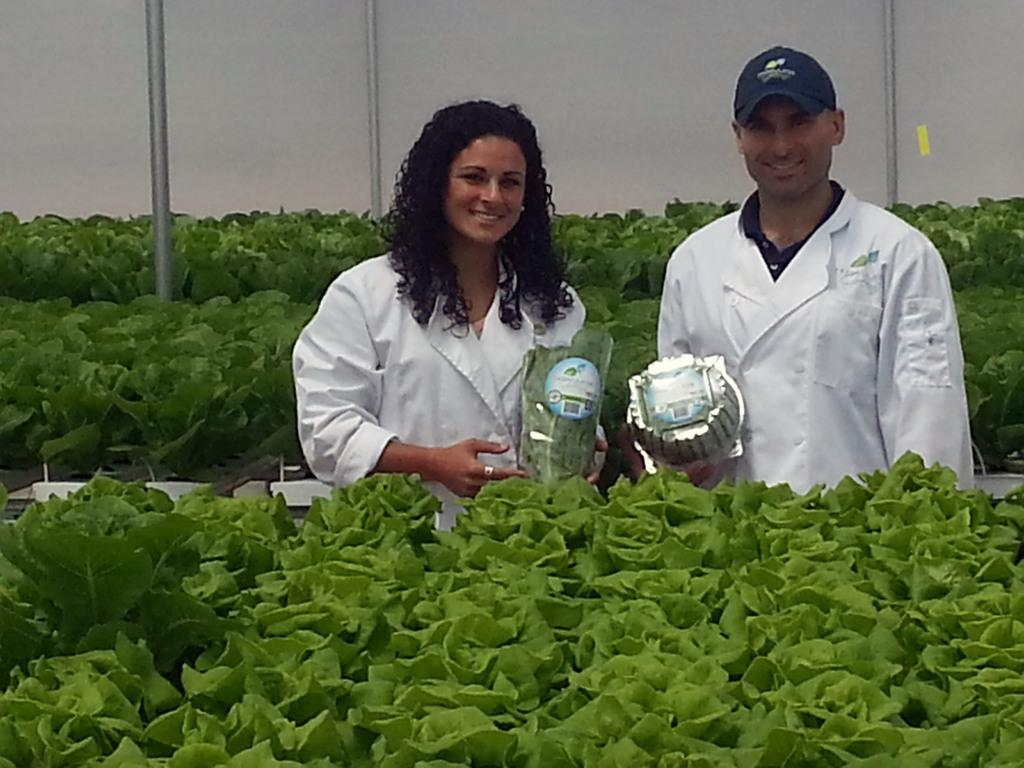How many people are in the image? There are two persons standing in the image. What are the persons holding in the image? The persons are holding objects. What type of vegetation can be seen in the image? There are plants with green color in the image. What can be seen in the background of the image? There are poles visible in the background of the image. What type of lace can be seen on the unit in the image? There is no unit or lace present in the image. How does the push of the object affect the movement of the persons in the image? There is no object being pushed in the image, and therefore no effect on the movement of the persons. 